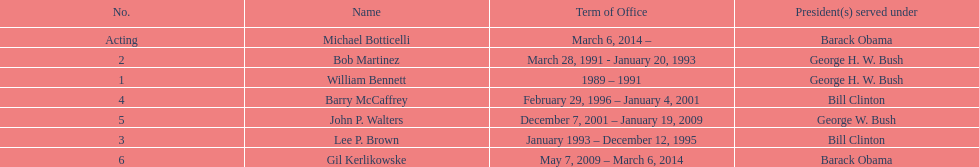How long did the first director serve in office? 2 years. 